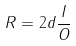<formula> <loc_0><loc_0><loc_500><loc_500>R = 2 d \frac { I } { O }</formula> 